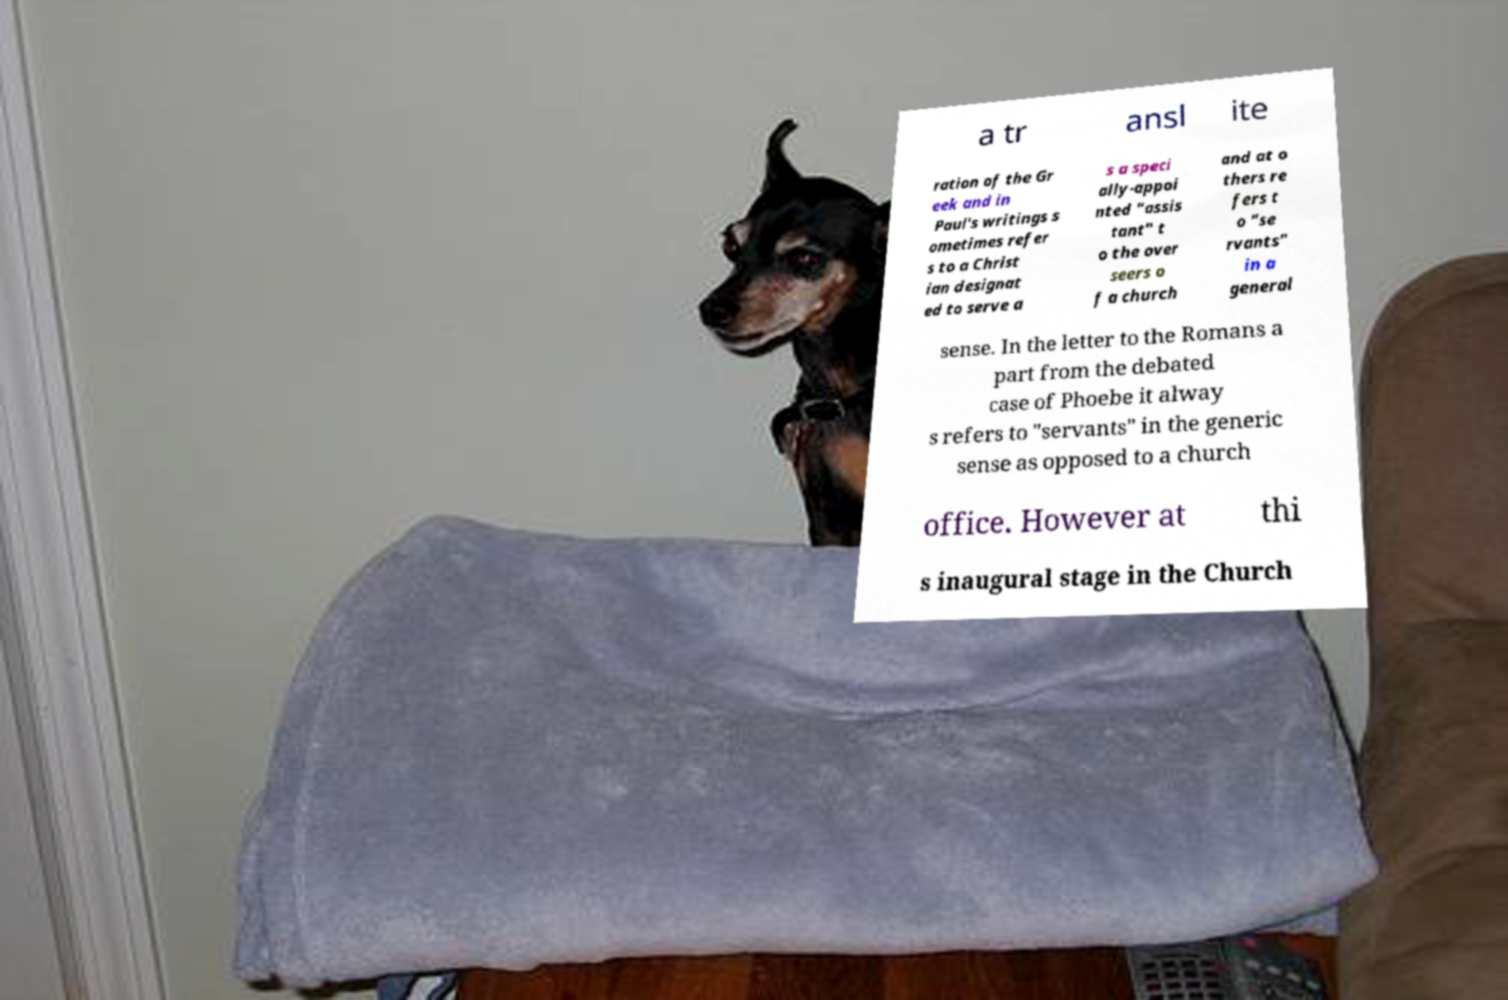For documentation purposes, I need the text within this image transcribed. Could you provide that? a tr ansl ite ration of the Gr eek and in Paul's writings s ometimes refer s to a Christ ian designat ed to serve a s a speci ally-appoi nted "assis tant" t o the over seers o f a church and at o thers re fers t o "se rvants" in a general sense. In the letter to the Romans a part from the debated case of Phoebe it alway s refers to "servants" in the generic sense as opposed to a church office. However at thi s inaugural stage in the Church 